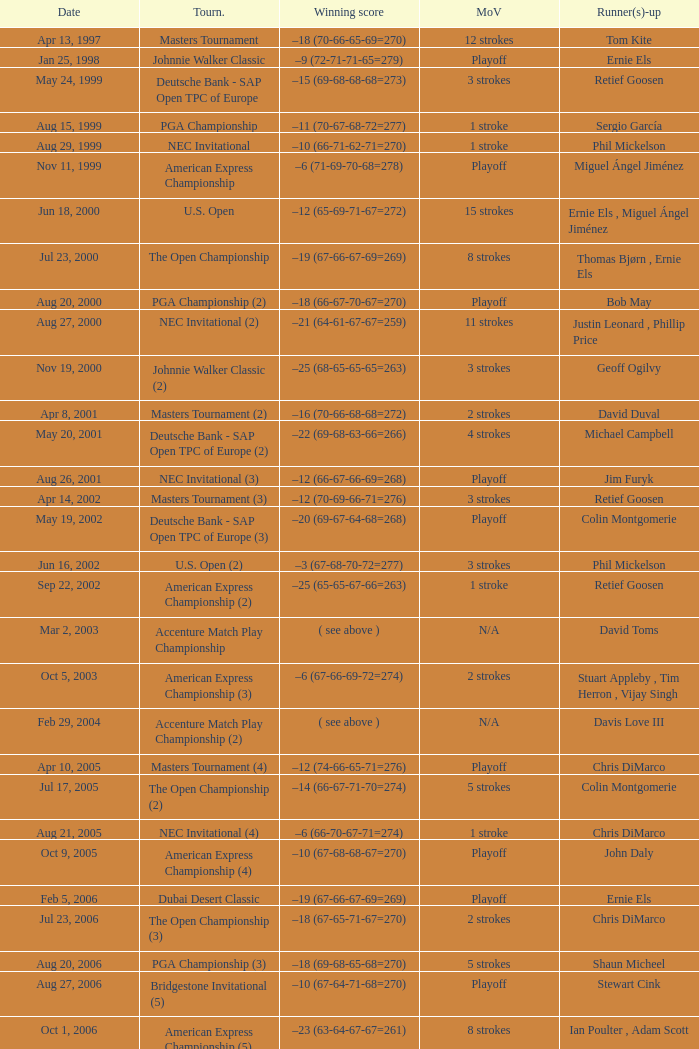Which Tournament has a Margin of victory of 7 strokes Bridgestone Invitational (8). 